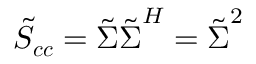Convert formula to latex. <formula><loc_0><loc_0><loc_500><loc_500>\tilde { S } _ { c c } = \tilde { \Sigma } \tilde { \Sigma } ^ { H } = \tilde { \Sigma } ^ { 2 }</formula> 